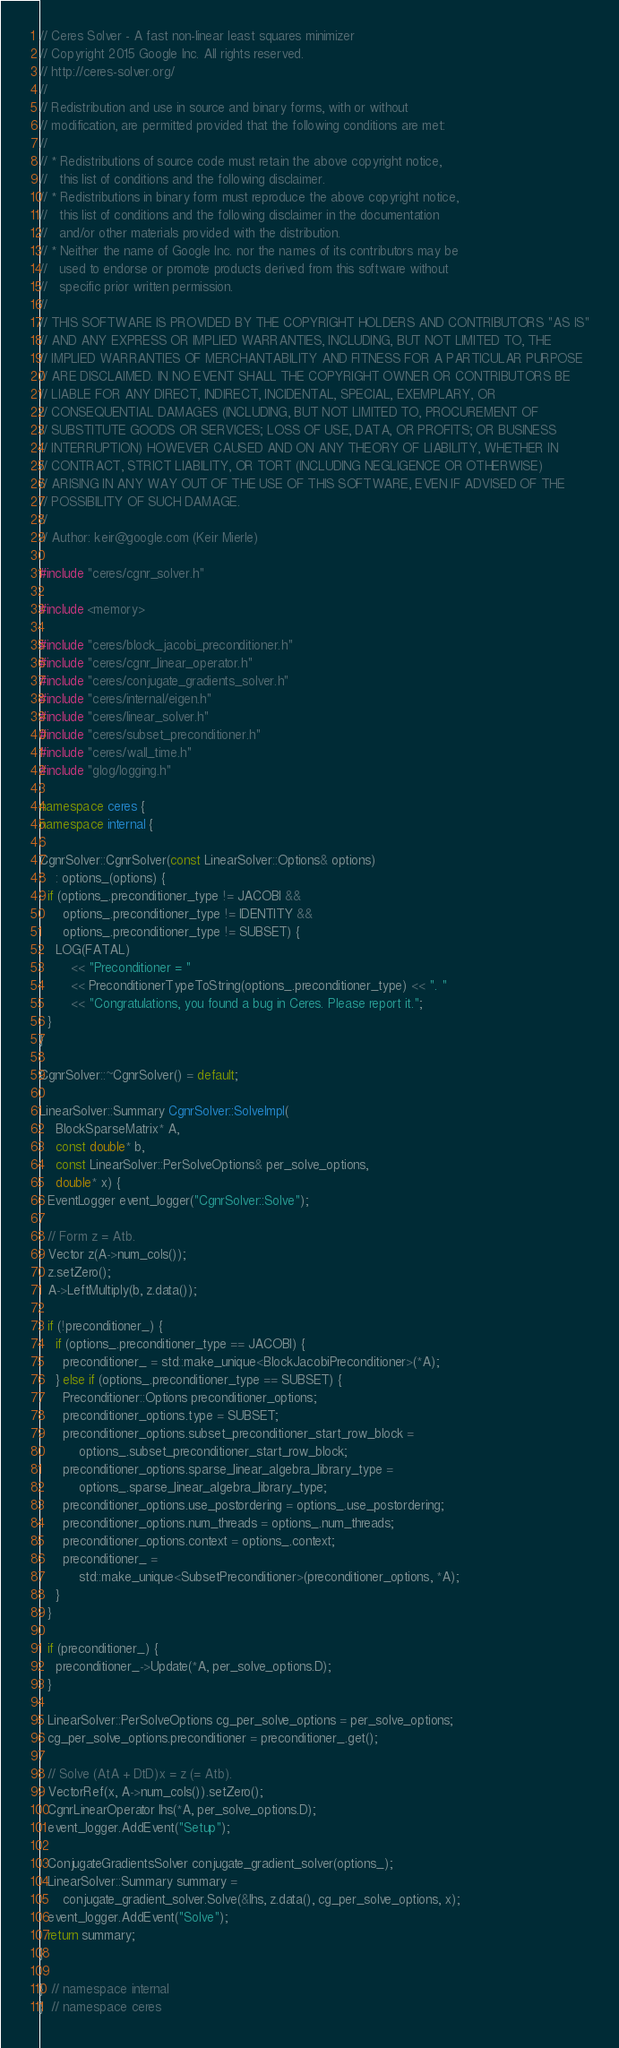Convert code to text. <code><loc_0><loc_0><loc_500><loc_500><_C++_>// Ceres Solver - A fast non-linear least squares minimizer
// Copyright 2015 Google Inc. All rights reserved.
// http://ceres-solver.org/
//
// Redistribution and use in source and binary forms, with or without
// modification, are permitted provided that the following conditions are met:
//
// * Redistributions of source code must retain the above copyright notice,
//   this list of conditions and the following disclaimer.
// * Redistributions in binary form must reproduce the above copyright notice,
//   this list of conditions and the following disclaimer in the documentation
//   and/or other materials provided with the distribution.
// * Neither the name of Google Inc. nor the names of its contributors may be
//   used to endorse or promote products derived from this software without
//   specific prior written permission.
//
// THIS SOFTWARE IS PROVIDED BY THE COPYRIGHT HOLDERS AND CONTRIBUTORS "AS IS"
// AND ANY EXPRESS OR IMPLIED WARRANTIES, INCLUDING, BUT NOT LIMITED TO, THE
// IMPLIED WARRANTIES OF MERCHANTABILITY AND FITNESS FOR A PARTICULAR PURPOSE
// ARE DISCLAIMED. IN NO EVENT SHALL THE COPYRIGHT OWNER OR CONTRIBUTORS BE
// LIABLE FOR ANY DIRECT, INDIRECT, INCIDENTAL, SPECIAL, EXEMPLARY, OR
// CONSEQUENTIAL DAMAGES (INCLUDING, BUT NOT LIMITED TO, PROCUREMENT OF
// SUBSTITUTE GOODS OR SERVICES; LOSS OF USE, DATA, OR PROFITS; OR BUSINESS
// INTERRUPTION) HOWEVER CAUSED AND ON ANY THEORY OF LIABILITY, WHETHER IN
// CONTRACT, STRICT LIABILITY, OR TORT (INCLUDING NEGLIGENCE OR OTHERWISE)
// ARISING IN ANY WAY OUT OF THE USE OF THIS SOFTWARE, EVEN IF ADVISED OF THE
// POSSIBILITY OF SUCH DAMAGE.
//
// Author: keir@google.com (Keir Mierle)

#include "ceres/cgnr_solver.h"

#include <memory>

#include "ceres/block_jacobi_preconditioner.h"
#include "ceres/cgnr_linear_operator.h"
#include "ceres/conjugate_gradients_solver.h"
#include "ceres/internal/eigen.h"
#include "ceres/linear_solver.h"
#include "ceres/subset_preconditioner.h"
#include "ceres/wall_time.h"
#include "glog/logging.h"

namespace ceres {
namespace internal {

CgnrSolver::CgnrSolver(const LinearSolver::Options& options)
    : options_(options) {
  if (options_.preconditioner_type != JACOBI &&
      options_.preconditioner_type != IDENTITY &&
      options_.preconditioner_type != SUBSET) {
    LOG(FATAL)
        << "Preconditioner = "
        << PreconditionerTypeToString(options_.preconditioner_type) << ". "
        << "Congratulations, you found a bug in Ceres. Please report it.";
  }
}

CgnrSolver::~CgnrSolver() = default;

LinearSolver::Summary CgnrSolver::SolveImpl(
    BlockSparseMatrix* A,
    const double* b,
    const LinearSolver::PerSolveOptions& per_solve_options,
    double* x) {
  EventLogger event_logger("CgnrSolver::Solve");

  // Form z = Atb.
  Vector z(A->num_cols());
  z.setZero();
  A->LeftMultiply(b, z.data());

  if (!preconditioner_) {
    if (options_.preconditioner_type == JACOBI) {
      preconditioner_ = std::make_unique<BlockJacobiPreconditioner>(*A);
    } else if (options_.preconditioner_type == SUBSET) {
      Preconditioner::Options preconditioner_options;
      preconditioner_options.type = SUBSET;
      preconditioner_options.subset_preconditioner_start_row_block =
          options_.subset_preconditioner_start_row_block;
      preconditioner_options.sparse_linear_algebra_library_type =
          options_.sparse_linear_algebra_library_type;
      preconditioner_options.use_postordering = options_.use_postordering;
      preconditioner_options.num_threads = options_.num_threads;
      preconditioner_options.context = options_.context;
      preconditioner_ =
          std::make_unique<SubsetPreconditioner>(preconditioner_options, *A);
    }
  }

  if (preconditioner_) {
    preconditioner_->Update(*A, per_solve_options.D);
  }

  LinearSolver::PerSolveOptions cg_per_solve_options = per_solve_options;
  cg_per_solve_options.preconditioner = preconditioner_.get();

  // Solve (AtA + DtD)x = z (= Atb).
  VectorRef(x, A->num_cols()).setZero();
  CgnrLinearOperator lhs(*A, per_solve_options.D);
  event_logger.AddEvent("Setup");

  ConjugateGradientsSolver conjugate_gradient_solver(options_);
  LinearSolver::Summary summary =
      conjugate_gradient_solver.Solve(&lhs, z.data(), cg_per_solve_options, x);
  event_logger.AddEvent("Solve");
  return summary;
}

}  // namespace internal
}  // namespace ceres
</code> 